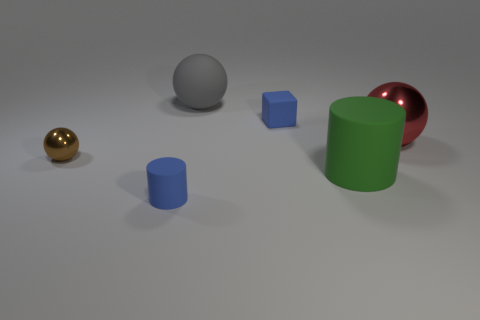There is a red object that is the same shape as the brown thing; what material is it?
Your answer should be very brief. Metal. What number of small blue rubber objects are to the left of the tiny blue thing behind the big red metal ball?
Your response must be concise. 1. There is a metal sphere behind the metallic sphere that is left of the green cylinder that is to the right of the gray matte sphere; how big is it?
Offer a very short reply. Large. What color is the shiny thing that is on the right side of the cylinder left of the blue cube?
Your answer should be very brief. Red. What number of other things are made of the same material as the block?
Make the answer very short. 3. What number of other objects are there of the same color as the tiny rubber cube?
Make the answer very short. 1. What material is the cylinder in front of the big green cylinder that is in front of the gray sphere?
Your answer should be compact. Rubber. Is there a big green cylinder?
Your response must be concise. Yes. How big is the cylinder that is right of the large thing that is behind the large metal object?
Keep it short and to the point. Large. Are there more large rubber balls in front of the tiny brown metal sphere than small blue things behind the gray sphere?
Your answer should be very brief. No. 